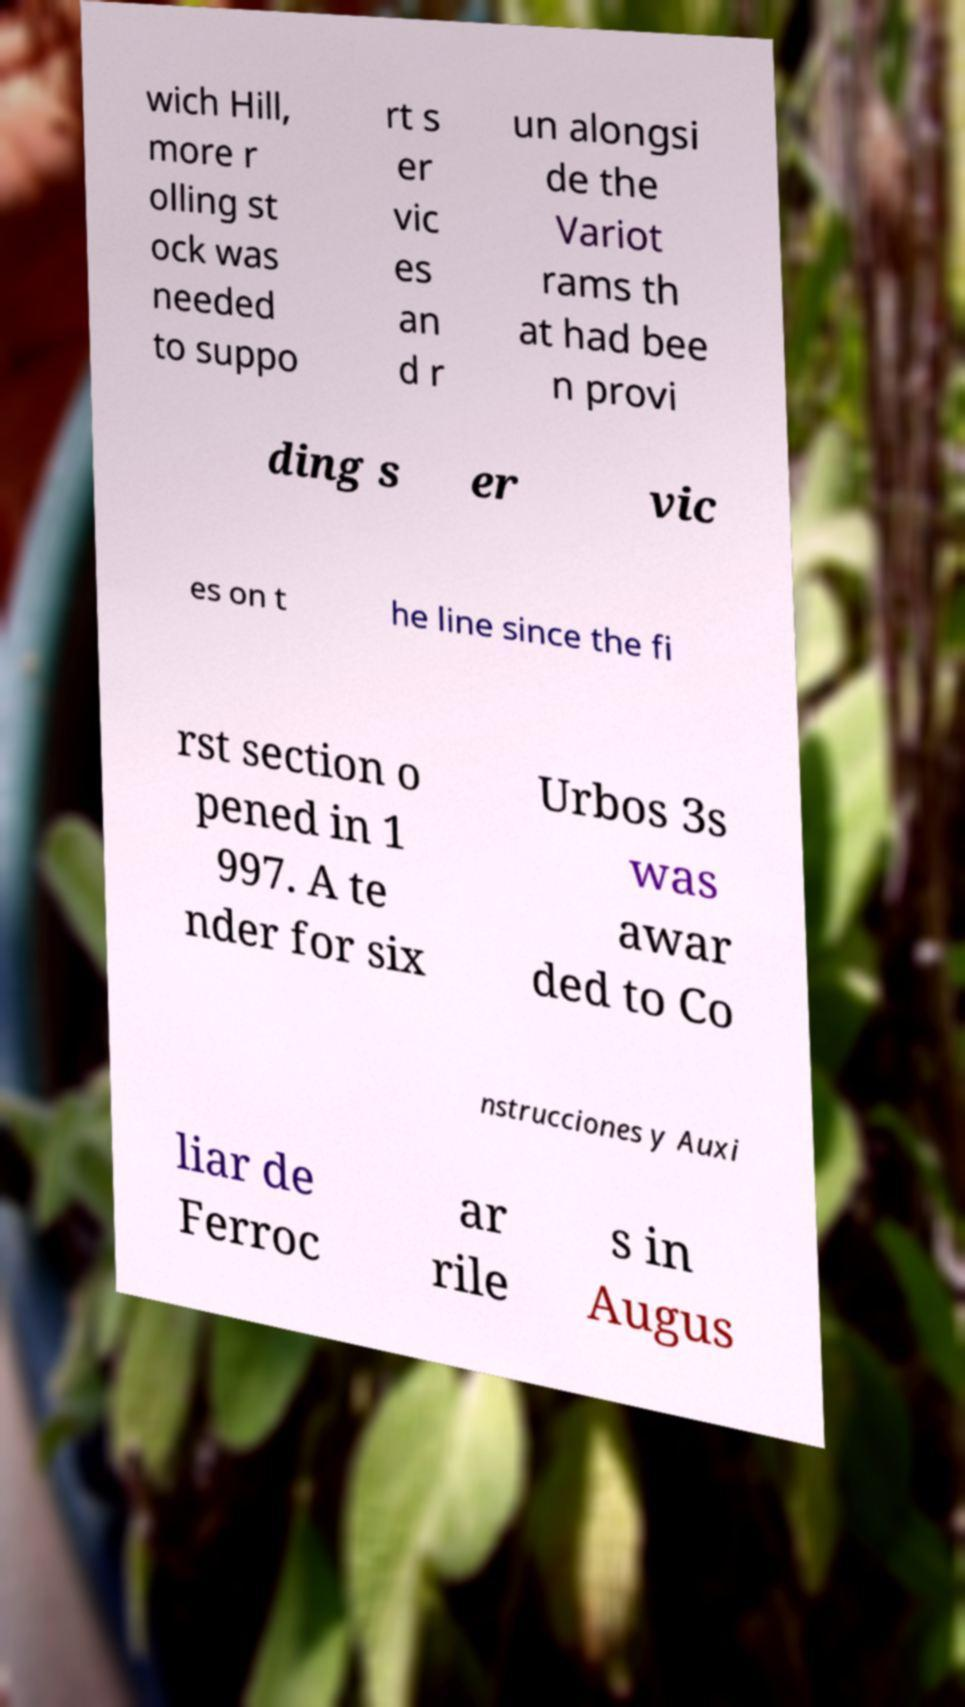Could you extract and type out the text from this image? wich Hill, more r olling st ock was needed to suppo rt s er vic es an d r un alongsi de the Variot rams th at had bee n provi ding s er vic es on t he line since the fi rst section o pened in 1 997. A te nder for six Urbos 3s was awar ded to Co nstrucciones y Auxi liar de Ferroc ar rile s in Augus 